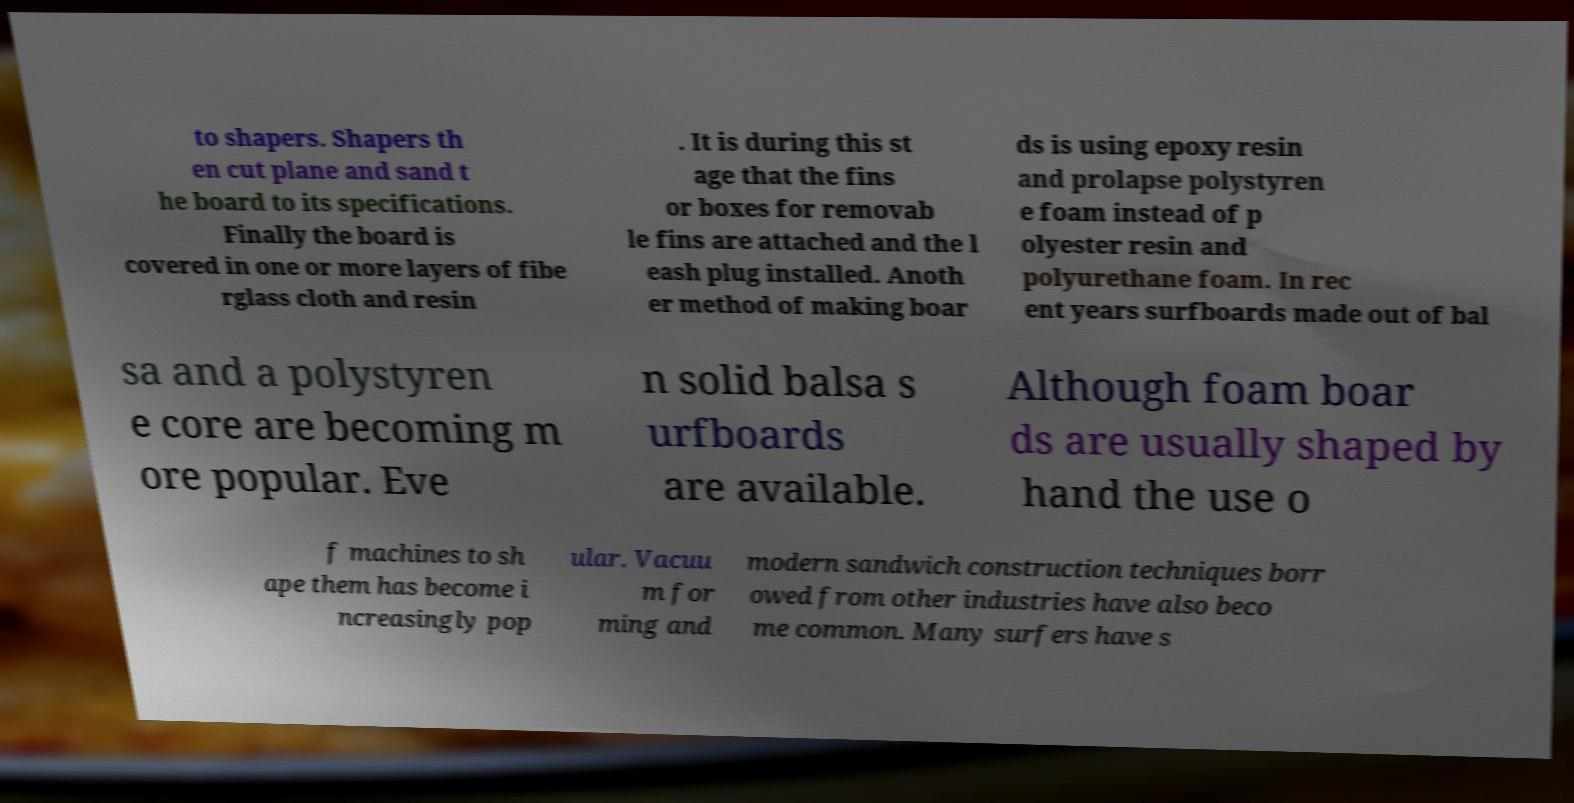Can you read and provide the text displayed in the image?This photo seems to have some interesting text. Can you extract and type it out for me? to shapers. Shapers th en cut plane and sand t he board to its specifications. Finally the board is covered in one or more layers of fibe rglass cloth and resin . It is during this st age that the fins or boxes for removab le fins are attached and the l eash plug installed. Anoth er method of making boar ds is using epoxy resin and prolapse polystyren e foam instead of p olyester resin and polyurethane foam. In rec ent years surfboards made out of bal sa and a polystyren e core are becoming m ore popular. Eve n solid balsa s urfboards are available. Although foam boar ds are usually shaped by hand the use o f machines to sh ape them has become i ncreasingly pop ular. Vacuu m for ming and modern sandwich construction techniques borr owed from other industries have also beco me common. Many surfers have s 